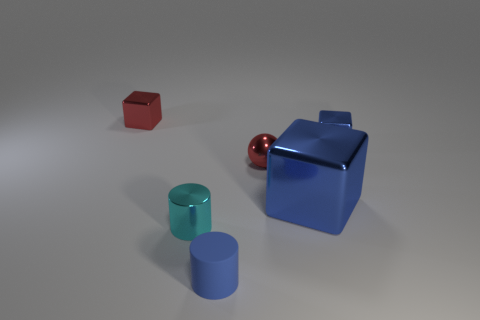Add 2 large blue things. How many objects exist? 8 Subtract all spheres. How many objects are left? 5 Add 1 big blue cubes. How many big blue cubes exist? 2 Subtract 1 red cubes. How many objects are left? 5 Subtract all small blue cylinders. Subtract all small matte cylinders. How many objects are left? 4 Add 3 blue rubber objects. How many blue rubber objects are left? 4 